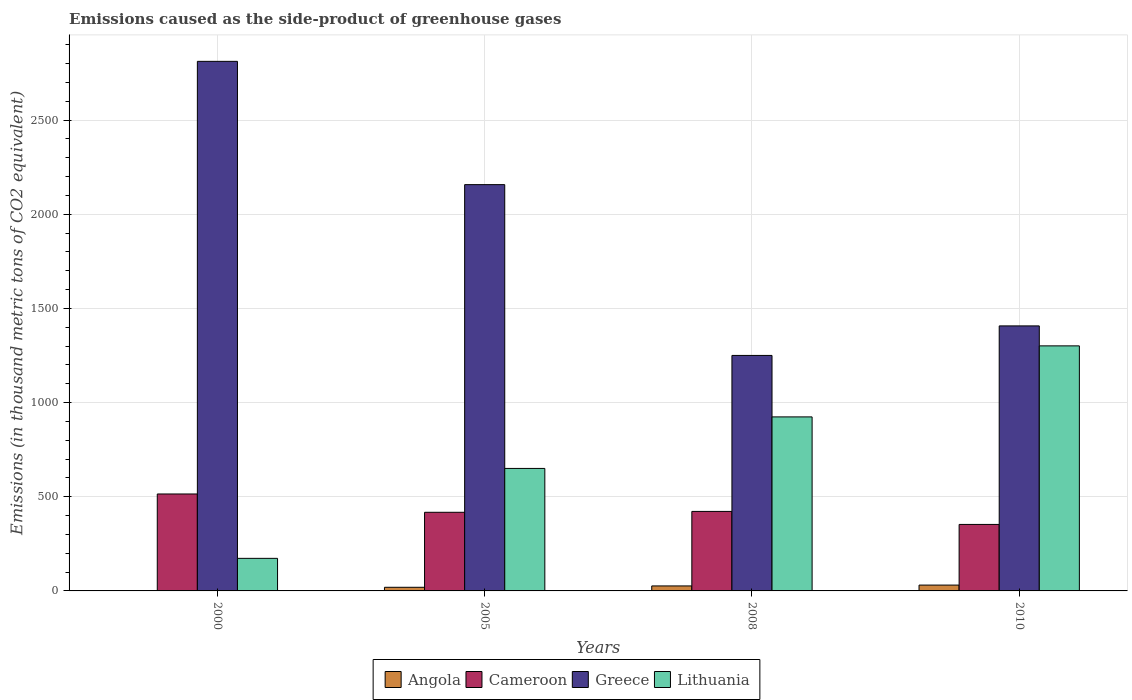How many different coloured bars are there?
Offer a terse response. 4. How many groups of bars are there?
Your response must be concise. 4. Are the number of bars per tick equal to the number of legend labels?
Keep it short and to the point. Yes. How many bars are there on the 1st tick from the left?
Your answer should be compact. 4. Across all years, what is the maximum emissions caused as the side-product of greenhouse gases in Lithuania?
Your answer should be compact. 1301. In which year was the emissions caused as the side-product of greenhouse gases in Greece maximum?
Your answer should be very brief. 2000. In which year was the emissions caused as the side-product of greenhouse gases in Greece minimum?
Keep it short and to the point. 2008. What is the total emissions caused as the side-product of greenhouse gases in Cameroon in the graph?
Offer a terse response. 1707.3. What is the difference between the emissions caused as the side-product of greenhouse gases in Lithuania in 2000 and that in 2010?
Provide a short and direct response. -1128.1. What is the difference between the emissions caused as the side-product of greenhouse gases in Angola in 2010 and the emissions caused as the side-product of greenhouse gases in Cameroon in 2005?
Your answer should be very brief. -386.5. What is the average emissions caused as the side-product of greenhouse gases in Greece per year?
Provide a short and direct response. 1906.42. In the year 2005, what is the difference between the emissions caused as the side-product of greenhouse gases in Cameroon and emissions caused as the side-product of greenhouse gases in Lithuania?
Offer a terse response. -232.8. In how many years, is the emissions caused as the side-product of greenhouse gases in Greece greater than 2400 thousand metric tons?
Your response must be concise. 1. What is the ratio of the emissions caused as the side-product of greenhouse gases in Greece in 2005 to that in 2008?
Give a very brief answer. 1.73. What is the difference between the highest and the second highest emissions caused as the side-product of greenhouse gases in Greece?
Offer a very short reply. 654.5. What is the difference between the highest and the lowest emissions caused as the side-product of greenhouse gases in Greece?
Ensure brevity in your answer.  1561.3. Is the sum of the emissions caused as the side-product of greenhouse gases in Greece in 2005 and 2010 greater than the maximum emissions caused as the side-product of greenhouse gases in Cameroon across all years?
Offer a terse response. Yes. Is it the case that in every year, the sum of the emissions caused as the side-product of greenhouse gases in Lithuania and emissions caused as the side-product of greenhouse gases in Greece is greater than the sum of emissions caused as the side-product of greenhouse gases in Angola and emissions caused as the side-product of greenhouse gases in Cameroon?
Ensure brevity in your answer.  Yes. What does the 1st bar from the left in 2010 represents?
Your response must be concise. Angola. What does the 1st bar from the right in 2000 represents?
Provide a succinct answer. Lithuania. What is the difference between two consecutive major ticks on the Y-axis?
Ensure brevity in your answer.  500. Does the graph contain any zero values?
Offer a very short reply. No. Where does the legend appear in the graph?
Offer a very short reply. Bottom center. What is the title of the graph?
Ensure brevity in your answer.  Emissions caused as the side-product of greenhouse gases. Does "OECD members" appear as one of the legend labels in the graph?
Offer a very short reply. No. What is the label or title of the Y-axis?
Give a very brief answer. Emissions (in thousand metric tons of CO2 equivalent). What is the Emissions (in thousand metric tons of CO2 equivalent) in Angola in 2000?
Offer a very short reply. 0.7. What is the Emissions (in thousand metric tons of CO2 equivalent) in Cameroon in 2000?
Your response must be concise. 514.7. What is the Emissions (in thousand metric tons of CO2 equivalent) of Greece in 2000?
Make the answer very short. 2811.5. What is the Emissions (in thousand metric tons of CO2 equivalent) of Lithuania in 2000?
Offer a very short reply. 172.9. What is the Emissions (in thousand metric tons of CO2 equivalent) of Angola in 2005?
Keep it short and to the point. 19.3. What is the Emissions (in thousand metric tons of CO2 equivalent) in Cameroon in 2005?
Offer a very short reply. 417.5. What is the Emissions (in thousand metric tons of CO2 equivalent) of Greece in 2005?
Provide a succinct answer. 2157. What is the Emissions (in thousand metric tons of CO2 equivalent) in Lithuania in 2005?
Your answer should be very brief. 650.3. What is the Emissions (in thousand metric tons of CO2 equivalent) in Angola in 2008?
Make the answer very short. 26.5. What is the Emissions (in thousand metric tons of CO2 equivalent) of Cameroon in 2008?
Ensure brevity in your answer.  422.1. What is the Emissions (in thousand metric tons of CO2 equivalent) of Greece in 2008?
Your answer should be very brief. 1250.2. What is the Emissions (in thousand metric tons of CO2 equivalent) in Lithuania in 2008?
Keep it short and to the point. 923.9. What is the Emissions (in thousand metric tons of CO2 equivalent) of Angola in 2010?
Ensure brevity in your answer.  31. What is the Emissions (in thousand metric tons of CO2 equivalent) of Cameroon in 2010?
Your response must be concise. 353. What is the Emissions (in thousand metric tons of CO2 equivalent) of Greece in 2010?
Make the answer very short. 1407. What is the Emissions (in thousand metric tons of CO2 equivalent) of Lithuania in 2010?
Make the answer very short. 1301. Across all years, what is the maximum Emissions (in thousand metric tons of CO2 equivalent) of Cameroon?
Make the answer very short. 514.7. Across all years, what is the maximum Emissions (in thousand metric tons of CO2 equivalent) in Greece?
Your response must be concise. 2811.5. Across all years, what is the maximum Emissions (in thousand metric tons of CO2 equivalent) of Lithuania?
Your response must be concise. 1301. Across all years, what is the minimum Emissions (in thousand metric tons of CO2 equivalent) of Cameroon?
Make the answer very short. 353. Across all years, what is the minimum Emissions (in thousand metric tons of CO2 equivalent) in Greece?
Offer a very short reply. 1250.2. Across all years, what is the minimum Emissions (in thousand metric tons of CO2 equivalent) of Lithuania?
Give a very brief answer. 172.9. What is the total Emissions (in thousand metric tons of CO2 equivalent) of Angola in the graph?
Offer a terse response. 77.5. What is the total Emissions (in thousand metric tons of CO2 equivalent) in Cameroon in the graph?
Make the answer very short. 1707.3. What is the total Emissions (in thousand metric tons of CO2 equivalent) in Greece in the graph?
Provide a succinct answer. 7625.7. What is the total Emissions (in thousand metric tons of CO2 equivalent) of Lithuania in the graph?
Keep it short and to the point. 3048.1. What is the difference between the Emissions (in thousand metric tons of CO2 equivalent) of Angola in 2000 and that in 2005?
Make the answer very short. -18.6. What is the difference between the Emissions (in thousand metric tons of CO2 equivalent) in Cameroon in 2000 and that in 2005?
Your answer should be very brief. 97.2. What is the difference between the Emissions (in thousand metric tons of CO2 equivalent) in Greece in 2000 and that in 2005?
Your answer should be very brief. 654.5. What is the difference between the Emissions (in thousand metric tons of CO2 equivalent) in Lithuania in 2000 and that in 2005?
Offer a very short reply. -477.4. What is the difference between the Emissions (in thousand metric tons of CO2 equivalent) of Angola in 2000 and that in 2008?
Provide a short and direct response. -25.8. What is the difference between the Emissions (in thousand metric tons of CO2 equivalent) of Cameroon in 2000 and that in 2008?
Your response must be concise. 92.6. What is the difference between the Emissions (in thousand metric tons of CO2 equivalent) of Greece in 2000 and that in 2008?
Your answer should be compact. 1561.3. What is the difference between the Emissions (in thousand metric tons of CO2 equivalent) in Lithuania in 2000 and that in 2008?
Make the answer very short. -751. What is the difference between the Emissions (in thousand metric tons of CO2 equivalent) in Angola in 2000 and that in 2010?
Offer a very short reply. -30.3. What is the difference between the Emissions (in thousand metric tons of CO2 equivalent) of Cameroon in 2000 and that in 2010?
Provide a short and direct response. 161.7. What is the difference between the Emissions (in thousand metric tons of CO2 equivalent) of Greece in 2000 and that in 2010?
Provide a succinct answer. 1404.5. What is the difference between the Emissions (in thousand metric tons of CO2 equivalent) in Lithuania in 2000 and that in 2010?
Keep it short and to the point. -1128.1. What is the difference between the Emissions (in thousand metric tons of CO2 equivalent) of Angola in 2005 and that in 2008?
Give a very brief answer. -7.2. What is the difference between the Emissions (in thousand metric tons of CO2 equivalent) in Greece in 2005 and that in 2008?
Provide a succinct answer. 906.8. What is the difference between the Emissions (in thousand metric tons of CO2 equivalent) of Lithuania in 2005 and that in 2008?
Make the answer very short. -273.6. What is the difference between the Emissions (in thousand metric tons of CO2 equivalent) of Angola in 2005 and that in 2010?
Your response must be concise. -11.7. What is the difference between the Emissions (in thousand metric tons of CO2 equivalent) of Cameroon in 2005 and that in 2010?
Your answer should be very brief. 64.5. What is the difference between the Emissions (in thousand metric tons of CO2 equivalent) of Greece in 2005 and that in 2010?
Provide a short and direct response. 750. What is the difference between the Emissions (in thousand metric tons of CO2 equivalent) of Lithuania in 2005 and that in 2010?
Your answer should be compact. -650.7. What is the difference between the Emissions (in thousand metric tons of CO2 equivalent) in Angola in 2008 and that in 2010?
Your answer should be compact. -4.5. What is the difference between the Emissions (in thousand metric tons of CO2 equivalent) of Cameroon in 2008 and that in 2010?
Offer a terse response. 69.1. What is the difference between the Emissions (in thousand metric tons of CO2 equivalent) in Greece in 2008 and that in 2010?
Provide a succinct answer. -156.8. What is the difference between the Emissions (in thousand metric tons of CO2 equivalent) in Lithuania in 2008 and that in 2010?
Provide a succinct answer. -377.1. What is the difference between the Emissions (in thousand metric tons of CO2 equivalent) in Angola in 2000 and the Emissions (in thousand metric tons of CO2 equivalent) in Cameroon in 2005?
Ensure brevity in your answer.  -416.8. What is the difference between the Emissions (in thousand metric tons of CO2 equivalent) of Angola in 2000 and the Emissions (in thousand metric tons of CO2 equivalent) of Greece in 2005?
Your answer should be compact. -2156.3. What is the difference between the Emissions (in thousand metric tons of CO2 equivalent) in Angola in 2000 and the Emissions (in thousand metric tons of CO2 equivalent) in Lithuania in 2005?
Ensure brevity in your answer.  -649.6. What is the difference between the Emissions (in thousand metric tons of CO2 equivalent) in Cameroon in 2000 and the Emissions (in thousand metric tons of CO2 equivalent) in Greece in 2005?
Your answer should be compact. -1642.3. What is the difference between the Emissions (in thousand metric tons of CO2 equivalent) in Cameroon in 2000 and the Emissions (in thousand metric tons of CO2 equivalent) in Lithuania in 2005?
Give a very brief answer. -135.6. What is the difference between the Emissions (in thousand metric tons of CO2 equivalent) of Greece in 2000 and the Emissions (in thousand metric tons of CO2 equivalent) of Lithuania in 2005?
Give a very brief answer. 2161.2. What is the difference between the Emissions (in thousand metric tons of CO2 equivalent) of Angola in 2000 and the Emissions (in thousand metric tons of CO2 equivalent) of Cameroon in 2008?
Make the answer very short. -421.4. What is the difference between the Emissions (in thousand metric tons of CO2 equivalent) of Angola in 2000 and the Emissions (in thousand metric tons of CO2 equivalent) of Greece in 2008?
Offer a very short reply. -1249.5. What is the difference between the Emissions (in thousand metric tons of CO2 equivalent) in Angola in 2000 and the Emissions (in thousand metric tons of CO2 equivalent) in Lithuania in 2008?
Keep it short and to the point. -923.2. What is the difference between the Emissions (in thousand metric tons of CO2 equivalent) in Cameroon in 2000 and the Emissions (in thousand metric tons of CO2 equivalent) in Greece in 2008?
Your answer should be very brief. -735.5. What is the difference between the Emissions (in thousand metric tons of CO2 equivalent) of Cameroon in 2000 and the Emissions (in thousand metric tons of CO2 equivalent) of Lithuania in 2008?
Provide a succinct answer. -409.2. What is the difference between the Emissions (in thousand metric tons of CO2 equivalent) in Greece in 2000 and the Emissions (in thousand metric tons of CO2 equivalent) in Lithuania in 2008?
Your response must be concise. 1887.6. What is the difference between the Emissions (in thousand metric tons of CO2 equivalent) in Angola in 2000 and the Emissions (in thousand metric tons of CO2 equivalent) in Cameroon in 2010?
Keep it short and to the point. -352.3. What is the difference between the Emissions (in thousand metric tons of CO2 equivalent) in Angola in 2000 and the Emissions (in thousand metric tons of CO2 equivalent) in Greece in 2010?
Your answer should be very brief. -1406.3. What is the difference between the Emissions (in thousand metric tons of CO2 equivalent) in Angola in 2000 and the Emissions (in thousand metric tons of CO2 equivalent) in Lithuania in 2010?
Your answer should be compact. -1300.3. What is the difference between the Emissions (in thousand metric tons of CO2 equivalent) in Cameroon in 2000 and the Emissions (in thousand metric tons of CO2 equivalent) in Greece in 2010?
Your answer should be very brief. -892.3. What is the difference between the Emissions (in thousand metric tons of CO2 equivalent) in Cameroon in 2000 and the Emissions (in thousand metric tons of CO2 equivalent) in Lithuania in 2010?
Your answer should be compact. -786.3. What is the difference between the Emissions (in thousand metric tons of CO2 equivalent) of Greece in 2000 and the Emissions (in thousand metric tons of CO2 equivalent) of Lithuania in 2010?
Provide a short and direct response. 1510.5. What is the difference between the Emissions (in thousand metric tons of CO2 equivalent) in Angola in 2005 and the Emissions (in thousand metric tons of CO2 equivalent) in Cameroon in 2008?
Your answer should be compact. -402.8. What is the difference between the Emissions (in thousand metric tons of CO2 equivalent) in Angola in 2005 and the Emissions (in thousand metric tons of CO2 equivalent) in Greece in 2008?
Provide a short and direct response. -1230.9. What is the difference between the Emissions (in thousand metric tons of CO2 equivalent) of Angola in 2005 and the Emissions (in thousand metric tons of CO2 equivalent) of Lithuania in 2008?
Provide a succinct answer. -904.6. What is the difference between the Emissions (in thousand metric tons of CO2 equivalent) of Cameroon in 2005 and the Emissions (in thousand metric tons of CO2 equivalent) of Greece in 2008?
Provide a short and direct response. -832.7. What is the difference between the Emissions (in thousand metric tons of CO2 equivalent) in Cameroon in 2005 and the Emissions (in thousand metric tons of CO2 equivalent) in Lithuania in 2008?
Provide a succinct answer. -506.4. What is the difference between the Emissions (in thousand metric tons of CO2 equivalent) in Greece in 2005 and the Emissions (in thousand metric tons of CO2 equivalent) in Lithuania in 2008?
Give a very brief answer. 1233.1. What is the difference between the Emissions (in thousand metric tons of CO2 equivalent) of Angola in 2005 and the Emissions (in thousand metric tons of CO2 equivalent) of Cameroon in 2010?
Ensure brevity in your answer.  -333.7. What is the difference between the Emissions (in thousand metric tons of CO2 equivalent) of Angola in 2005 and the Emissions (in thousand metric tons of CO2 equivalent) of Greece in 2010?
Ensure brevity in your answer.  -1387.7. What is the difference between the Emissions (in thousand metric tons of CO2 equivalent) in Angola in 2005 and the Emissions (in thousand metric tons of CO2 equivalent) in Lithuania in 2010?
Provide a short and direct response. -1281.7. What is the difference between the Emissions (in thousand metric tons of CO2 equivalent) in Cameroon in 2005 and the Emissions (in thousand metric tons of CO2 equivalent) in Greece in 2010?
Your response must be concise. -989.5. What is the difference between the Emissions (in thousand metric tons of CO2 equivalent) of Cameroon in 2005 and the Emissions (in thousand metric tons of CO2 equivalent) of Lithuania in 2010?
Provide a short and direct response. -883.5. What is the difference between the Emissions (in thousand metric tons of CO2 equivalent) in Greece in 2005 and the Emissions (in thousand metric tons of CO2 equivalent) in Lithuania in 2010?
Make the answer very short. 856. What is the difference between the Emissions (in thousand metric tons of CO2 equivalent) in Angola in 2008 and the Emissions (in thousand metric tons of CO2 equivalent) in Cameroon in 2010?
Make the answer very short. -326.5. What is the difference between the Emissions (in thousand metric tons of CO2 equivalent) in Angola in 2008 and the Emissions (in thousand metric tons of CO2 equivalent) in Greece in 2010?
Provide a succinct answer. -1380.5. What is the difference between the Emissions (in thousand metric tons of CO2 equivalent) in Angola in 2008 and the Emissions (in thousand metric tons of CO2 equivalent) in Lithuania in 2010?
Give a very brief answer. -1274.5. What is the difference between the Emissions (in thousand metric tons of CO2 equivalent) of Cameroon in 2008 and the Emissions (in thousand metric tons of CO2 equivalent) of Greece in 2010?
Offer a terse response. -984.9. What is the difference between the Emissions (in thousand metric tons of CO2 equivalent) of Cameroon in 2008 and the Emissions (in thousand metric tons of CO2 equivalent) of Lithuania in 2010?
Make the answer very short. -878.9. What is the difference between the Emissions (in thousand metric tons of CO2 equivalent) of Greece in 2008 and the Emissions (in thousand metric tons of CO2 equivalent) of Lithuania in 2010?
Your answer should be very brief. -50.8. What is the average Emissions (in thousand metric tons of CO2 equivalent) in Angola per year?
Make the answer very short. 19.38. What is the average Emissions (in thousand metric tons of CO2 equivalent) of Cameroon per year?
Offer a terse response. 426.82. What is the average Emissions (in thousand metric tons of CO2 equivalent) of Greece per year?
Keep it short and to the point. 1906.42. What is the average Emissions (in thousand metric tons of CO2 equivalent) of Lithuania per year?
Provide a short and direct response. 762.02. In the year 2000, what is the difference between the Emissions (in thousand metric tons of CO2 equivalent) of Angola and Emissions (in thousand metric tons of CO2 equivalent) of Cameroon?
Your answer should be compact. -514. In the year 2000, what is the difference between the Emissions (in thousand metric tons of CO2 equivalent) in Angola and Emissions (in thousand metric tons of CO2 equivalent) in Greece?
Your response must be concise. -2810.8. In the year 2000, what is the difference between the Emissions (in thousand metric tons of CO2 equivalent) of Angola and Emissions (in thousand metric tons of CO2 equivalent) of Lithuania?
Your response must be concise. -172.2. In the year 2000, what is the difference between the Emissions (in thousand metric tons of CO2 equivalent) in Cameroon and Emissions (in thousand metric tons of CO2 equivalent) in Greece?
Give a very brief answer. -2296.8. In the year 2000, what is the difference between the Emissions (in thousand metric tons of CO2 equivalent) in Cameroon and Emissions (in thousand metric tons of CO2 equivalent) in Lithuania?
Give a very brief answer. 341.8. In the year 2000, what is the difference between the Emissions (in thousand metric tons of CO2 equivalent) of Greece and Emissions (in thousand metric tons of CO2 equivalent) of Lithuania?
Give a very brief answer. 2638.6. In the year 2005, what is the difference between the Emissions (in thousand metric tons of CO2 equivalent) in Angola and Emissions (in thousand metric tons of CO2 equivalent) in Cameroon?
Offer a terse response. -398.2. In the year 2005, what is the difference between the Emissions (in thousand metric tons of CO2 equivalent) in Angola and Emissions (in thousand metric tons of CO2 equivalent) in Greece?
Your answer should be very brief. -2137.7. In the year 2005, what is the difference between the Emissions (in thousand metric tons of CO2 equivalent) in Angola and Emissions (in thousand metric tons of CO2 equivalent) in Lithuania?
Your response must be concise. -631. In the year 2005, what is the difference between the Emissions (in thousand metric tons of CO2 equivalent) in Cameroon and Emissions (in thousand metric tons of CO2 equivalent) in Greece?
Your answer should be compact. -1739.5. In the year 2005, what is the difference between the Emissions (in thousand metric tons of CO2 equivalent) of Cameroon and Emissions (in thousand metric tons of CO2 equivalent) of Lithuania?
Ensure brevity in your answer.  -232.8. In the year 2005, what is the difference between the Emissions (in thousand metric tons of CO2 equivalent) in Greece and Emissions (in thousand metric tons of CO2 equivalent) in Lithuania?
Provide a succinct answer. 1506.7. In the year 2008, what is the difference between the Emissions (in thousand metric tons of CO2 equivalent) of Angola and Emissions (in thousand metric tons of CO2 equivalent) of Cameroon?
Keep it short and to the point. -395.6. In the year 2008, what is the difference between the Emissions (in thousand metric tons of CO2 equivalent) in Angola and Emissions (in thousand metric tons of CO2 equivalent) in Greece?
Your answer should be very brief. -1223.7. In the year 2008, what is the difference between the Emissions (in thousand metric tons of CO2 equivalent) in Angola and Emissions (in thousand metric tons of CO2 equivalent) in Lithuania?
Give a very brief answer. -897.4. In the year 2008, what is the difference between the Emissions (in thousand metric tons of CO2 equivalent) in Cameroon and Emissions (in thousand metric tons of CO2 equivalent) in Greece?
Offer a very short reply. -828.1. In the year 2008, what is the difference between the Emissions (in thousand metric tons of CO2 equivalent) of Cameroon and Emissions (in thousand metric tons of CO2 equivalent) of Lithuania?
Keep it short and to the point. -501.8. In the year 2008, what is the difference between the Emissions (in thousand metric tons of CO2 equivalent) of Greece and Emissions (in thousand metric tons of CO2 equivalent) of Lithuania?
Keep it short and to the point. 326.3. In the year 2010, what is the difference between the Emissions (in thousand metric tons of CO2 equivalent) in Angola and Emissions (in thousand metric tons of CO2 equivalent) in Cameroon?
Your response must be concise. -322. In the year 2010, what is the difference between the Emissions (in thousand metric tons of CO2 equivalent) in Angola and Emissions (in thousand metric tons of CO2 equivalent) in Greece?
Your answer should be very brief. -1376. In the year 2010, what is the difference between the Emissions (in thousand metric tons of CO2 equivalent) of Angola and Emissions (in thousand metric tons of CO2 equivalent) of Lithuania?
Your answer should be compact. -1270. In the year 2010, what is the difference between the Emissions (in thousand metric tons of CO2 equivalent) in Cameroon and Emissions (in thousand metric tons of CO2 equivalent) in Greece?
Offer a very short reply. -1054. In the year 2010, what is the difference between the Emissions (in thousand metric tons of CO2 equivalent) of Cameroon and Emissions (in thousand metric tons of CO2 equivalent) of Lithuania?
Provide a short and direct response. -948. In the year 2010, what is the difference between the Emissions (in thousand metric tons of CO2 equivalent) in Greece and Emissions (in thousand metric tons of CO2 equivalent) in Lithuania?
Make the answer very short. 106. What is the ratio of the Emissions (in thousand metric tons of CO2 equivalent) in Angola in 2000 to that in 2005?
Your answer should be very brief. 0.04. What is the ratio of the Emissions (in thousand metric tons of CO2 equivalent) of Cameroon in 2000 to that in 2005?
Ensure brevity in your answer.  1.23. What is the ratio of the Emissions (in thousand metric tons of CO2 equivalent) of Greece in 2000 to that in 2005?
Your answer should be compact. 1.3. What is the ratio of the Emissions (in thousand metric tons of CO2 equivalent) in Lithuania in 2000 to that in 2005?
Make the answer very short. 0.27. What is the ratio of the Emissions (in thousand metric tons of CO2 equivalent) of Angola in 2000 to that in 2008?
Offer a very short reply. 0.03. What is the ratio of the Emissions (in thousand metric tons of CO2 equivalent) of Cameroon in 2000 to that in 2008?
Provide a succinct answer. 1.22. What is the ratio of the Emissions (in thousand metric tons of CO2 equivalent) of Greece in 2000 to that in 2008?
Give a very brief answer. 2.25. What is the ratio of the Emissions (in thousand metric tons of CO2 equivalent) of Lithuania in 2000 to that in 2008?
Give a very brief answer. 0.19. What is the ratio of the Emissions (in thousand metric tons of CO2 equivalent) of Angola in 2000 to that in 2010?
Give a very brief answer. 0.02. What is the ratio of the Emissions (in thousand metric tons of CO2 equivalent) of Cameroon in 2000 to that in 2010?
Your response must be concise. 1.46. What is the ratio of the Emissions (in thousand metric tons of CO2 equivalent) in Greece in 2000 to that in 2010?
Your answer should be very brief. 2. What is the ratio of the Emissions (in thousand metric tons of CO2 equivalent) in Lithuania in 2000 to that in 2010?
Provide a succinct answer. 0.13. What is the ratio of the Emissions (in thousand metric tons of CO2 equivalent) of Angola in 2005 to that in 2008?
Provide a short and direct response. 0.73. What is the ratio of the Emissions (in thousand metric tons of CO2 equivalent) of Cameroon in 2005 to that in 2008?
Keep it short and to the point. 0.99. What is the ratio of the Emissions (in thousand metric tons of CO2 equivalent) of Greece in 2005 to that in 2008?
Provide a short and direct response. 1.73. What is the ratio of the Emissions (in thousand metric tons of CO2 equivalent) in Lithuania in 2005 to that in 2008?
Your answer should be compact. 0.7. What is the ratio of the Emissions (in thousand metric tons of CO2 equivalent) of Angola in 2005 to that in 2010?
Give a very brief answer. 0.62. What is the ratio of the Emissions (in thousand metric tons of CO2 equivalent) in Cameroon in 2005 to that in 2010?
Give a very brief answer. 1.18. What is the ratio of the Emissions (in thousand metric tons of CO2 equivalent) of Greece in 2005 to that in 2010?
Keep it short and to the point. 1.53. What is the ratio of the Emissions (in thousand metric tons of CO2 equivalent) of Lithuania in 2005 to that in 2010?
Your response must be concise. 0.5. What is the ratio of the Emissions (in thousand metric tons of CO2 equivalent) of Angola in 2008 to that in 2010?
Your answer should be very brief. 0.85. What is the ratio of the Emissions (in thousand metric tons of CO2 equivalent) in Cameroon in 2008 to that in 2010?
Provide a succinct answer. 1.2. What is the ratio of the Emissions (in thousand metric tons of CO2 equivalent) in Greece in 2008 to that in 2010?
Offer a terse response. 0.89. What is the ratio of the Emissions (in thousand metric tons of CO2 equivalent) of Lithuania in 2008 to that in 2010?
Keep it short and to the point. 0.71. What is the difference between the highest and the second highest Emissions (in thousand metric tons of CO2 equivalent) of Cameroon?
Keep it short and to the point. 92.6. What is the difference between the highest and the second highest Emissions (in thousand metric tons of CO2 equivalent) of Greece?
Provide a short and direct response. 654.5. What is the difference between the highest and the second highest Emissions (in thousand metric tons of CO2 equivalent) of Lithuania?
Make the answer very short. 377.1. What is the difference between the highest and the lowest Emissions (in thousand metric tons of CO2 equivalent) in Angola?
Ensure brevity in your answer.  30.3. What is the difference between the highest and the lowest Emissions (in thousand metric tons of CO2 equivalent) in Cameroon?
Offer a very short reply. 161.7. What is the difference between the highest and the lowest Emissions (in thousand metric tons of CO2 equivalent) of Greece?
Your answer should be compact. 1561.3. What is the difference between the highest and the lowest Emissions (in thousand metric tons of CO2 equivalent) in Lithuania?
Give a very brief answer. 1128.1. 